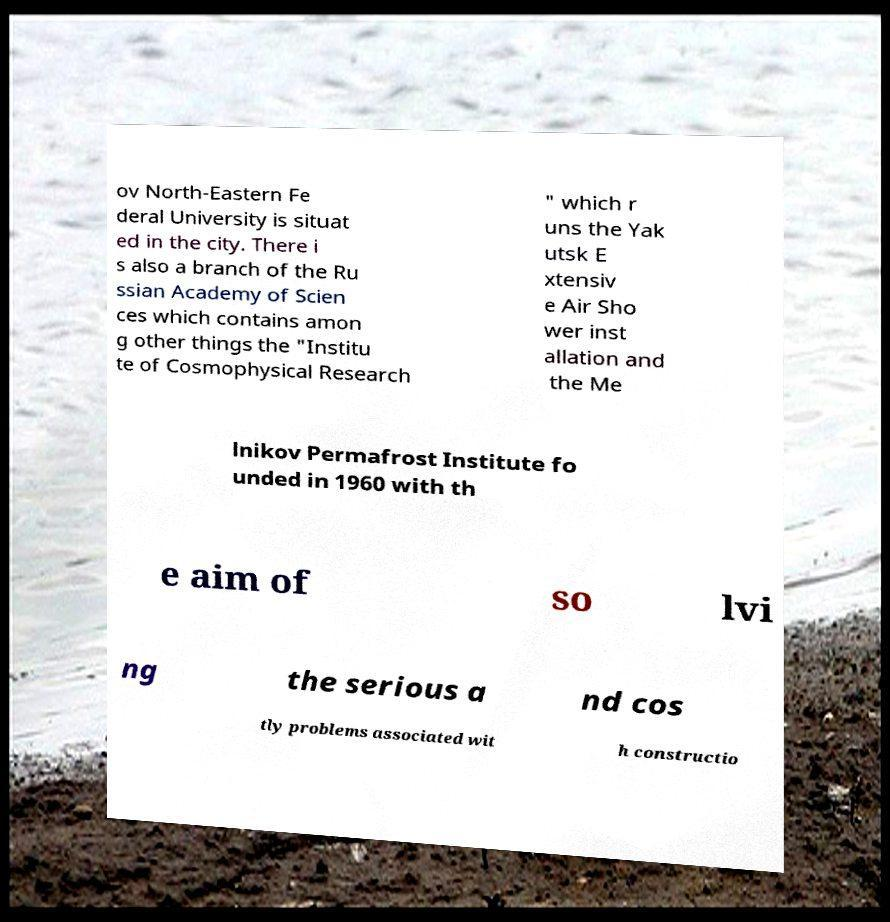Could you assist in decoding the text presented in this image and type it out clearly? ov North-Eastern Fe deral University is situat ed in the city. There i s also a branch of the Ru ssian Academy of Scien ces which contains amon g other things the "Institu te of Cosmophysical Research " which r uns the Yak utsk E xtensiv e Air Sho wer inst allation and the Me lnikov Permafrost Institute fo unded in 1960 with th e aim of so lvi ng the serious a nd cos tly problems associated wit h constructio 